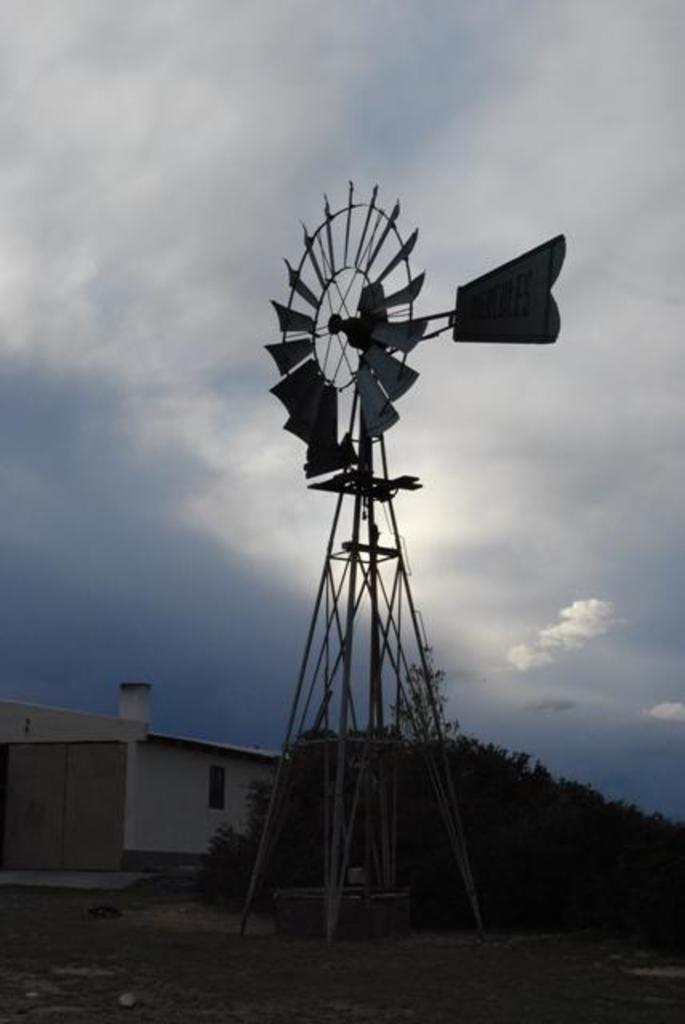In one or two sentences, can you explain what this image depicts? In this image, I can see a water windmill. At the bottom of the image, I can see a house and trees. In the background, there is the sky. 